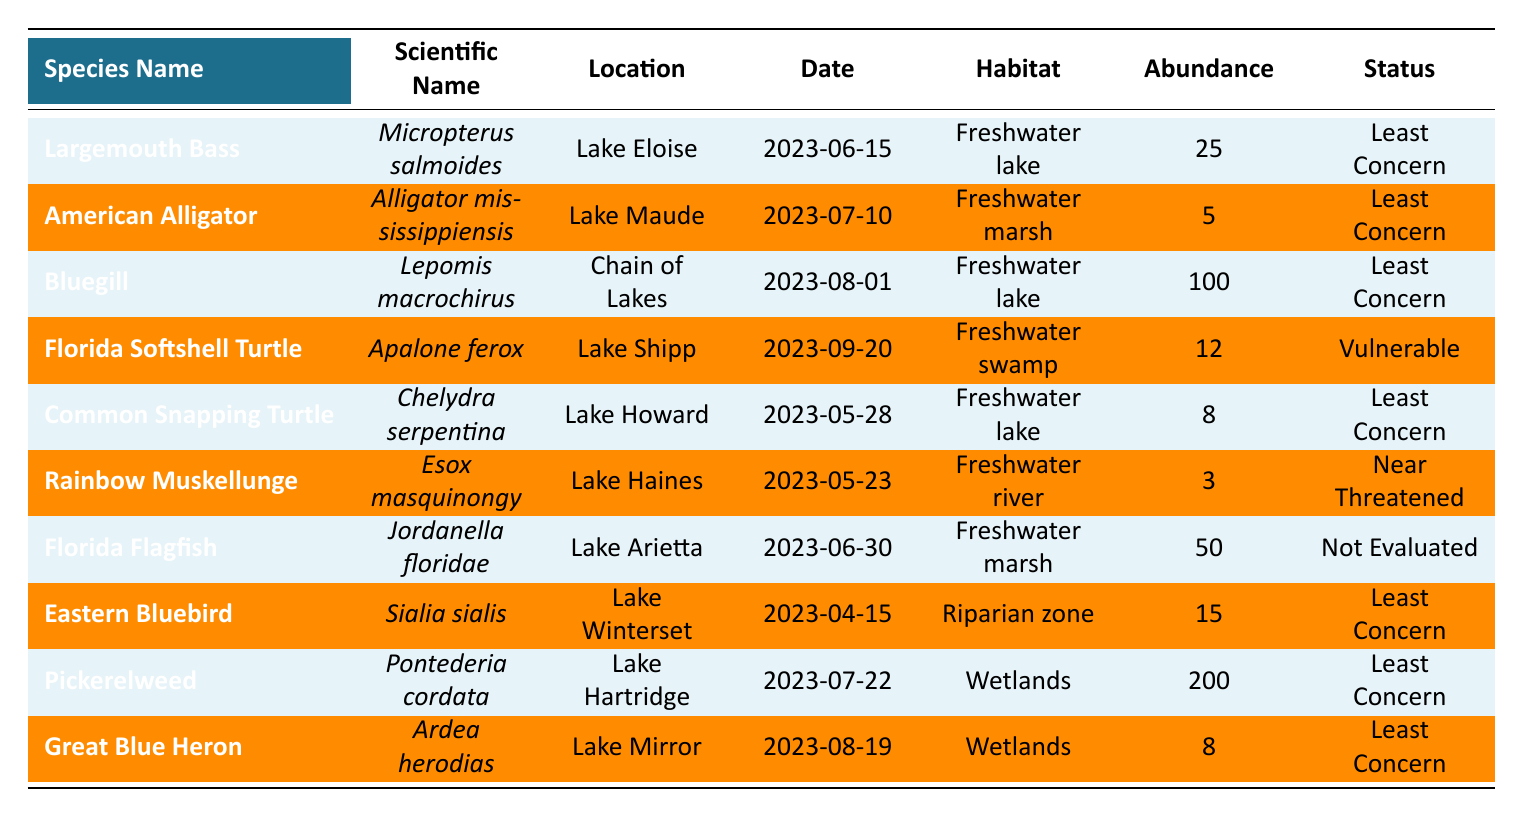What is the scientific name of the Bluegill? The table lists the species name as "Bluegill," and its corresponding scientific name is provided alongside it as "Lepomis macrochirus."
Answer: Lepomis macrochirus Which species observed in Lake Eloise has the highest abundance? The table shows that the "Largemouth Bass" is observed in Lake Eloise with an abundance of 25, which is the only species listed from that location, making it the highest.
Answer: Largemouth Bass What is the conservation status of the Florida Softshell Turtle? The table indicates that the Florida Softshell Turtle is listed under the conservation status as "Vulnerable."
Answer: Vulnerable How many species observed in freshwater marshes are listed as Least Concern? The table shows two species observed in freshwater marshes: "American Alligator" and "Florida Flagfish." Both are categorized as "Least Concern," so there are two species.
Answer: 2 What is the total abundance of species observed in all the freshwater lakes listed? The total abundance includes Largemouth Bass (25), Bluegill (100), Common Snapping Turtle (8), and Pickerelweed (200). Adding these gives 25 + 100 + 8 + 200 = 333.
Answer: 333 Is any species in the table listed as Endangered? The table does not show any species with a conservation status of "Endangered"; the closest is "Near Threatened" for the Rainbow Muskellunge. Therefore, the answer is no.
Answer: No Which habitat type has the highest observed abundance from the data? From the table, Pickerelweed has the highest abundance at 200, which is noted under Wetlands. No other habitat has a higher recorded abundance.
Answer: Wetlands Calculate the average abundance of species categorized as "Least Concern." The species listed as "Least Concern" are Largemouth Bass (25), Bluegill (100), Common Snapping Turtle (8), American Alligator (5), Eastern Bluebird (15), Florida Flagfish (50), Great Blue Heron (8), and Pickerelweed (200). The sum of the abundances is 25 + 100 + 8 + 5 + 15 + 50 + 8 + 200 = 411. There are 8 species, and the average is 411/8 = 51.375.
Answer: 51.375 What is the total number of species observed in wetlands? The table lists Pickerelweed and Great Blue Heron as species observed in wetlands, totaling two species.
Answer: 2 On what date was the Rainbow Muskellunge observed, and what was its conservation status? The table shows that the Rainbow Muskellunge was observed on "2023-05-23," and its conservation status is "Near Threatened."
Answer: Observed on 2023-05-23, Near Threatened 